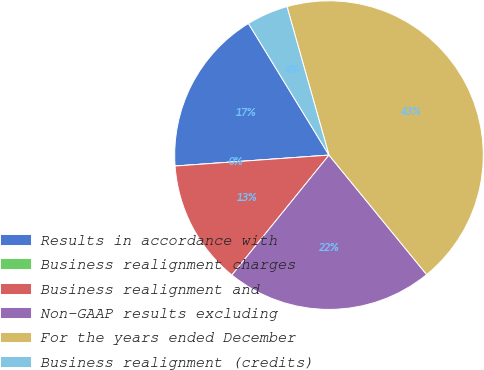Convert chart. <chart><loc_0><loc_0><loc_500><loc_500><pie_chart><fcel>Results in accordance with<fcel>Business realignment charges<fcel>Business realignment and<fcel>Non-GAAP results excluding<fcel>For the years ended December<fcel>Business realignment (credits)<nl><fcel>17.39%<fcel>0.0%<fcel>13.04%<fcel>21.74%<fcel>43.48%<fcel>4.35%<nl></chart> 